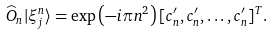<formula> <loc_0><loc_0><loc_500><loc_500>\widehat { O } _ { n } | \xi _ { j } ^ { n } \rangle & = \exp \left ( - i \pi n ^ { 2 } \right ) [ c _ { n } ^ { \prime } , c _ { n } ^ { \prime } , \dots , c _ { n } ^ { \prime } ] ^ { T } .</formula> 